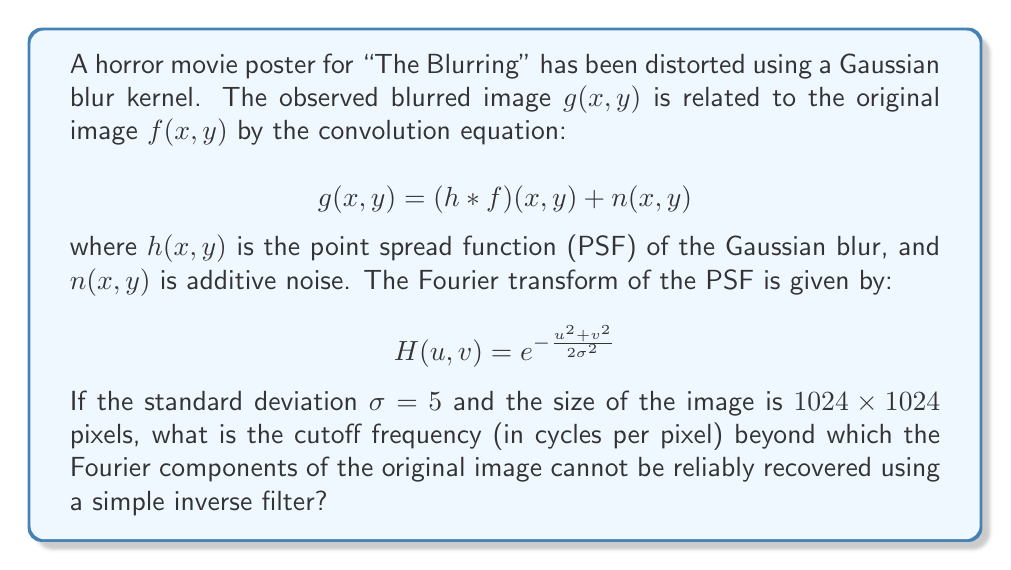Can you answer this question? To solve this problem, we need to follow these steps:

1) The inverse filter in the frequency domain is given by:

   $$F(u,v) = \frac{G(u,v)}{H(u,v)}$$

2) However, this becomes unstable when $H(u,v)$ is very small. We need to find the frequency at which $H(u,v)$ becomes too small to reliably invert.

3) A common criterion is to consider frequencies where $|H(u,v)| < 0.1$ as unreliable for inversion.

4) Using the given PSF in the frequency domain:

   $$|H(u,v)| = e^{-\frac{u^2 + v^2}{2\sigma^2}} < 0.1$$

5) Taking the natural log of both sides:

   $$-\frac{u^2 + v^2}{2\sigma^2} < \ln(0.1)$$

6) Solving for the radial frequency $\omega = \sqrt{u^2 + v^2}$:

   $$\omega^2 > -2\sigma^2 \ln(0.1)$$
   $$\omega > \sigma \sqrt{-2\ln(0.1)}$$

7) Substituting $\sigma = 5$:

   $$\omega > 5 \sqrt{-2\ln(0.1)} \approx 10.7$$

8) The cutoff frequency in cycles per pixel is this value divided by the image size (1024):

   $$f_c = \frac{10.7}{1024} \approx 0.0104$$

This cutoff frequency represents the limit beyond which the Fourier components of the original image cannot be reliably recovered using a simple inverse filter.
Answer: 0.0104 cycles per pixel 